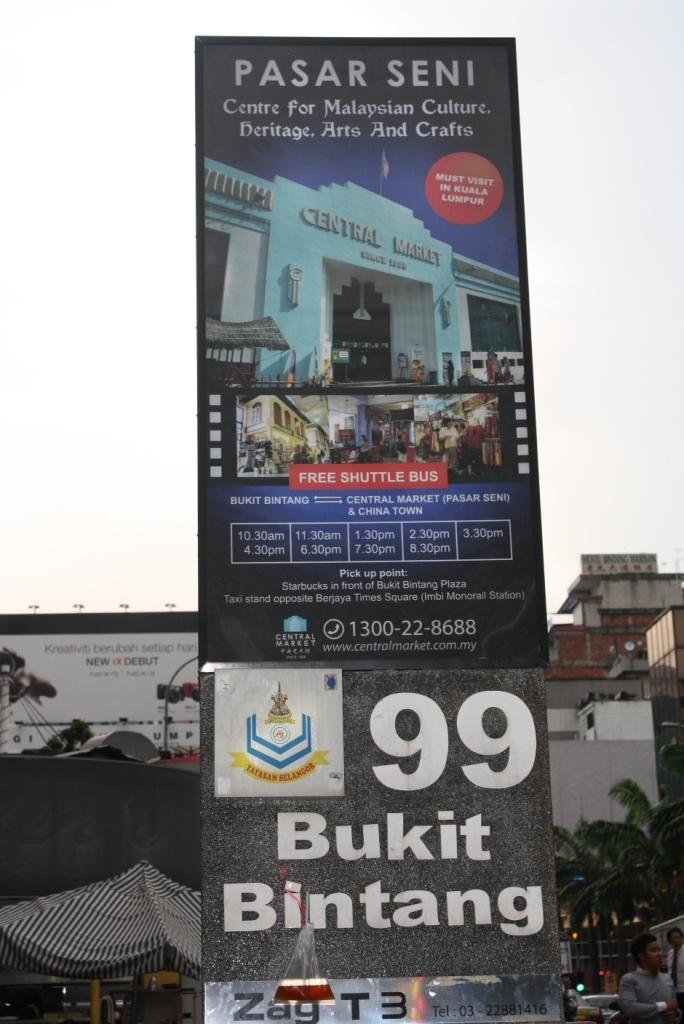What is the largest number on display here?
Give a very brief answer. 99. What is the two words of text at the top?
Give a very brief answer. Pasar seni. 